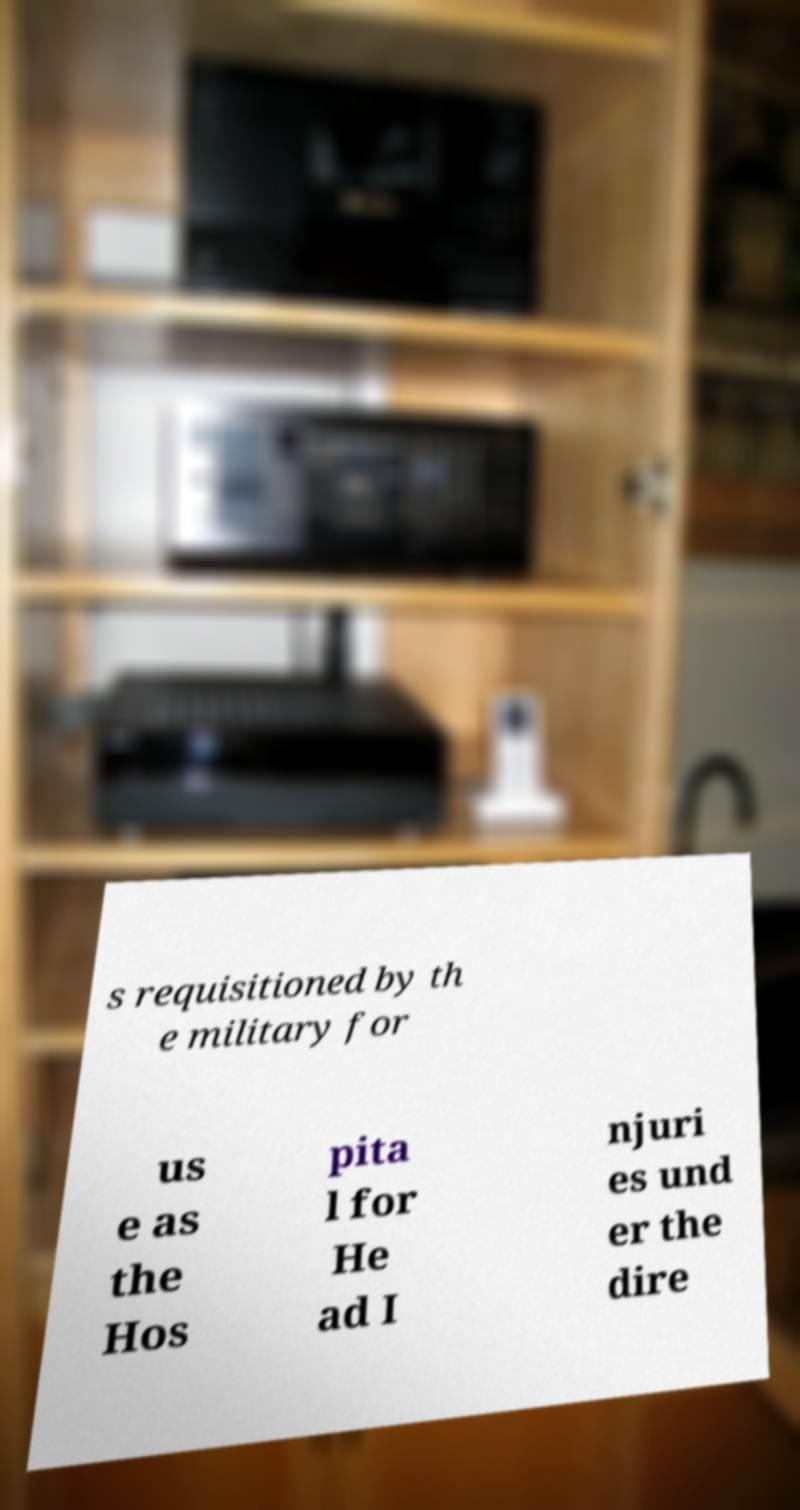There's text embedded in this image that I need extracted. Can you transcribe it verbatim? s requisitioned by th e military for us e as the Hos pita l for He ad I njuri es und er the dire 